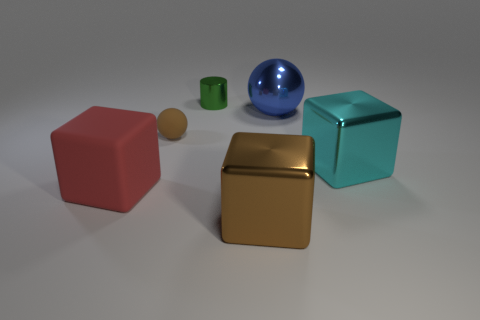Is the color of the big shiny thing in front of the cyan metallic thing the same as the tiny rubber thing?
Give a very brief answer. Yes. What number of other objects are there of the same color as the small ball?
Your answer should be very brief. 1. There is a blue object that is the same material as the green cylinder; what size is it?
Make the answer very short. Large. What color is the large cube that is to the left of the blue metal ball and on the right side of the small brown matte ball?
Your answer should be compact. Brown. What number of other green cylinders are the same size as the green cylinder?
Give a very brief answer. 0. How big is the object that is left of the tiny green object and behind the cyan metal thing?
Make the answer very short. Small. What number of big cyan metallic cubes are on the left side of the block to the left of the brown object that is to the left of the tiny metal object?
Provide a succinct answer. 0. Is there a cube that has the same color as the small matte thing?
Keep it short and to the point. Yes. What is the color of the object that is the same size as the brown rubber sphere?
Offer a very short reply. Green. There is a large metal thing in front of the block behind the big object that is on the left side of the tiny green thing; what shape is it?
Your answer should be very brief. Cube. 